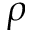<formula> <loc_0><loc_0><loc_500><loc_500>\rho</formula> 